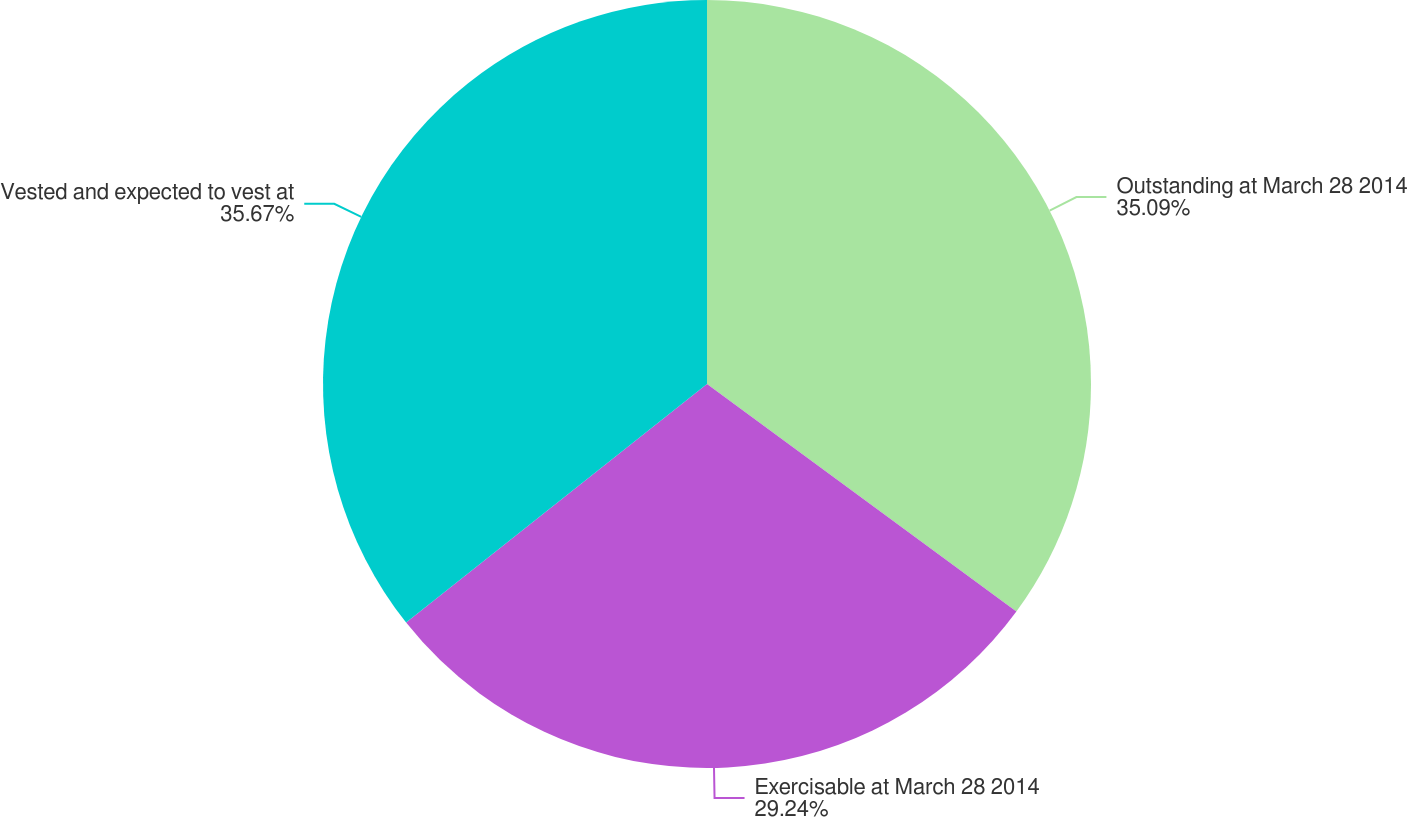Convert chart. <chart><loc_0><loc_0><loc_500><loc_500><pie_chart><fcel>Outstanding at March 28 2014<fcel>Exercisable at March 28 2014<fcel>Vested and expected to vest at<nl><fcel>35.09%<fcel>29.24%<fcel>35.67%<nl></chart> 